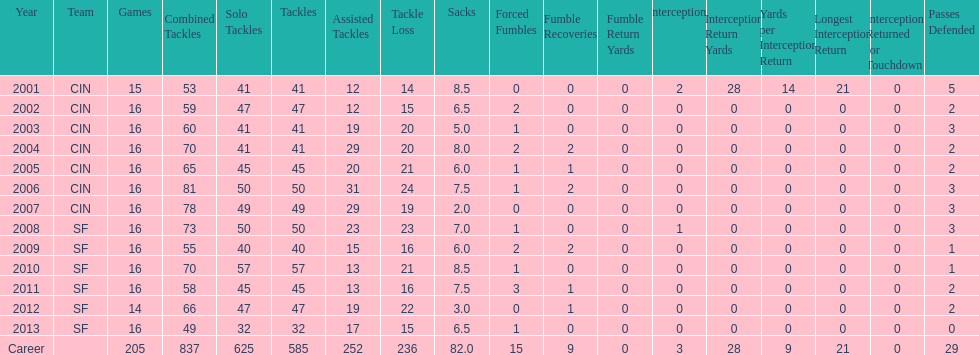How many seasons had combined tackles of 70 or more? 5. 